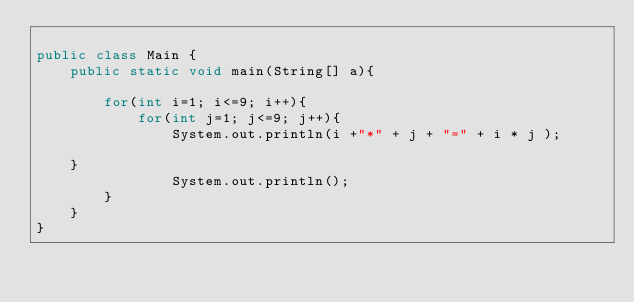<code> <loc_0><loc_0><loc_500><loc_500><_Java_>
public class Main {
	public static void main(String[] a){
		
		for(int i=1; i<=9; i++){
			for(int j=1; j<=9; j++){
				System.out.println(i +"*" + j + "=" + i * j );
				
	}
				System.out.println();
		}
	}
}</code> 